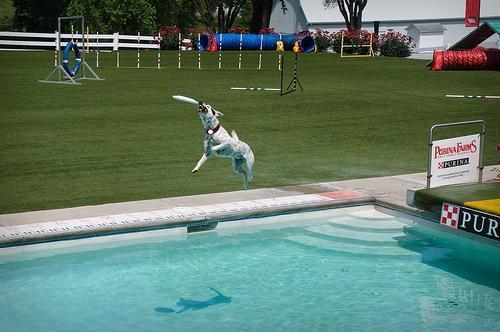How many animals are shown in the photo?
Give a very brief answer. 1. 